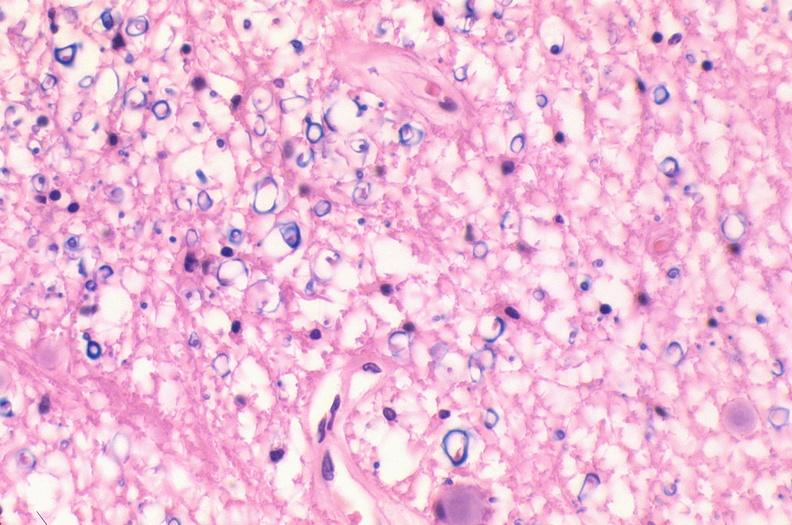why does this image show spinal cord injury?
Answer the question using a single word or phrase. Due to vertebral column trauma 